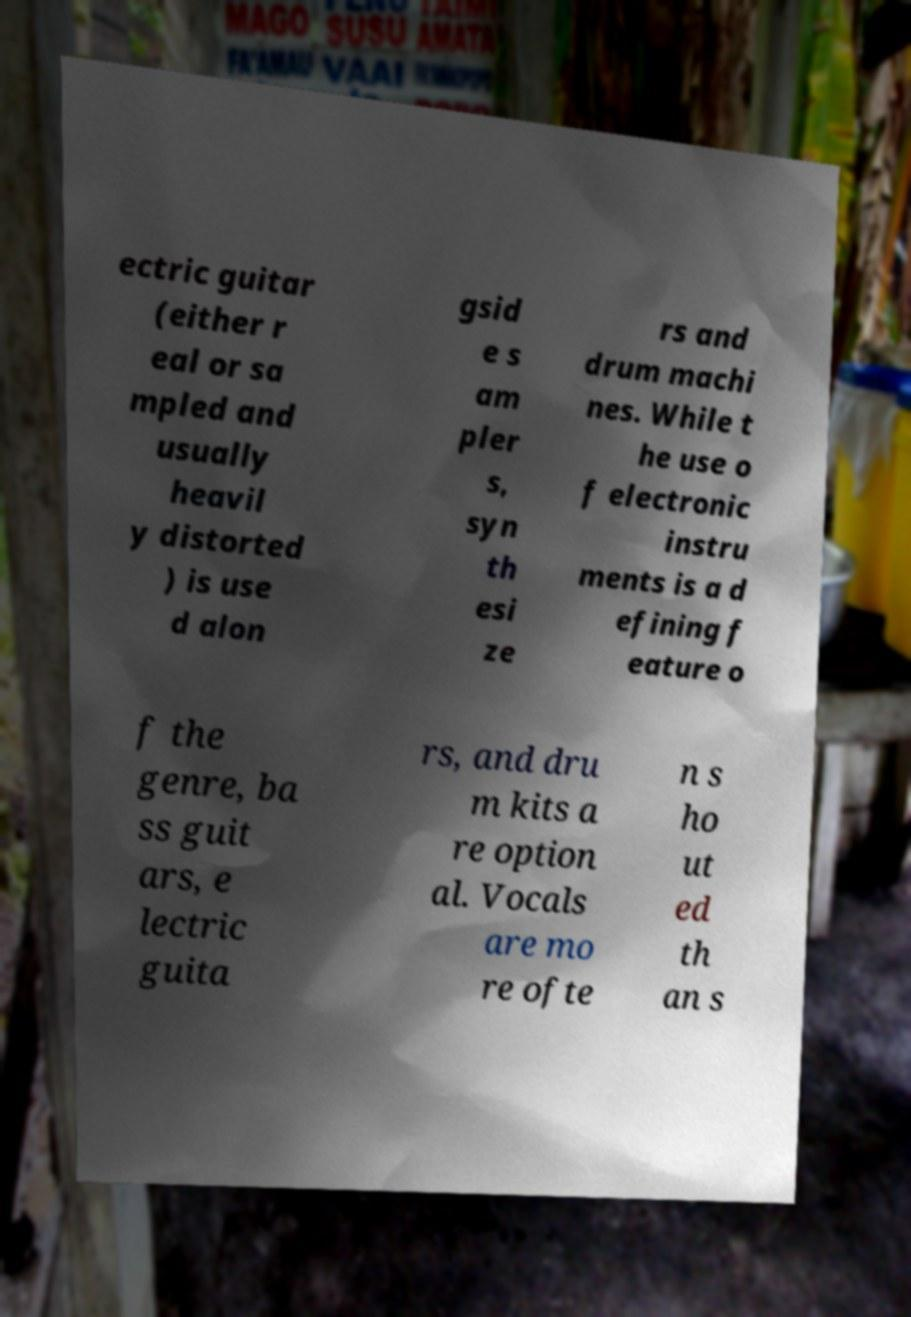Can you accurately transcribe the text from the provided image for me? ectric guitar (either r eal or sa mpled and usually heavil y distorted ) is use d alon gsid e s am pler s, syn th esi ze rs and drum machi nes. While t he use o f electronic instru ments is a d efining f eature o f the genre, ba ss guit ars, e lectric guita rs, and dru m kits a re option al. Vocals are mo re ofte n s ho ut ed th an s 